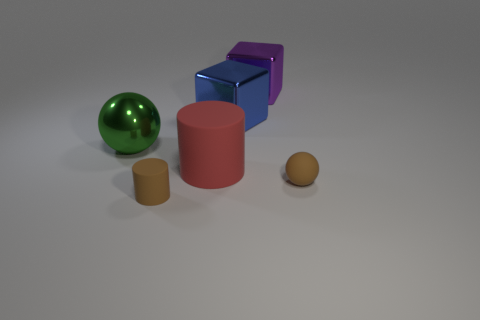There is a rubber cylinder behind the tiny brown rubber cylinder; what color is it?
Your response must be concise. Red. There is a matte cylinder that is to the right of the tiny object that is on the left side of the purple object; what size is it?
Offer a very short reply. Large. Is the shape of the brown rubber thing on the left side of the small matte ball the same as  the big green object?
Offer a very short reply. No. What is the material of the other thing that is the same shape as the big green metal object?
Your answer should be compact. Rubber. How many objects are small brown matte objects that are right of the big red cylinder or brown matte things that are behind the small rubber cylinder?
Offer a very short reply. 1. There is a small rubber ball; is it the same color as the rubber cylinder that is in front of the large red cylinder?
Ensure brevity in your answer.  Yes. What is the shape of the green thing that is the same material as the big blue object?
Your answer should be compact. Sphere. How many big cyan cylinders are there?
Your response must be concise. 0. What number of things are either small brown matte objects to the right of the big blue metal object or brown matte objects?
Give a very brief answer. 2. Do the tiny matte object that is in front of the small brown matte sphere and the small rubber sphere have the same color?
Ensure brevity in your answer.  Yes. 